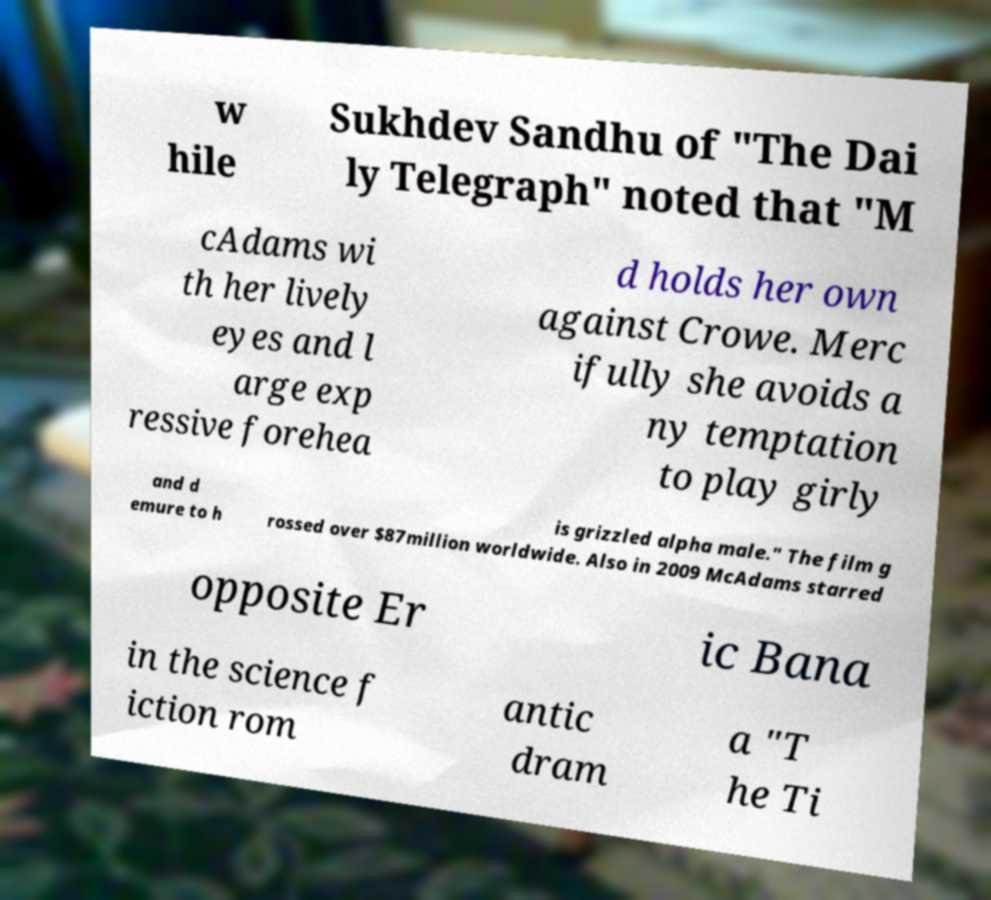Please identify and transcribe the text found in this image. w hile Sukhdev Sandhu of "The Dai ly Telegraph" noted that "M cAdams wi th her lively eyes and l arge exp ressive forehea d holds her own against Crowe. Merc ifully she avoids a ny temptation to play girly and d emure to h is grizzled alpha male." The film g rossed over $87million worldwide. Also in 2009 McAdams starred opposite Er ic Bana in the science f iction rom antic dram a "T he Ti 